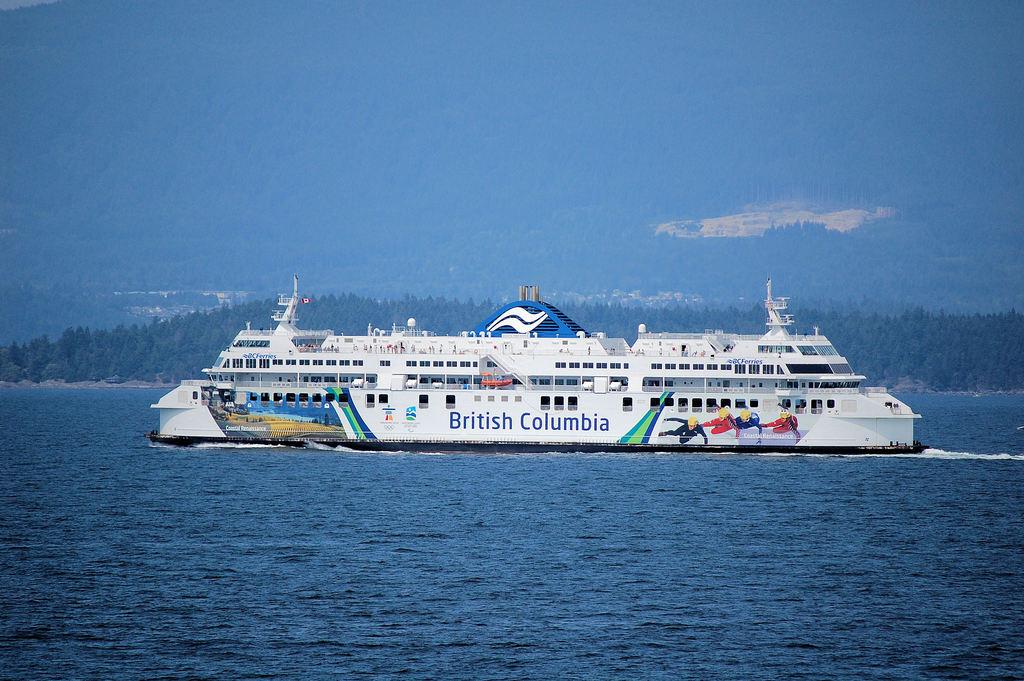What does it say on the side of the ship?
Your answer should be compact. British columbia. What country is written on the side of the ship?
Provide a short and direct response. British columbia. 